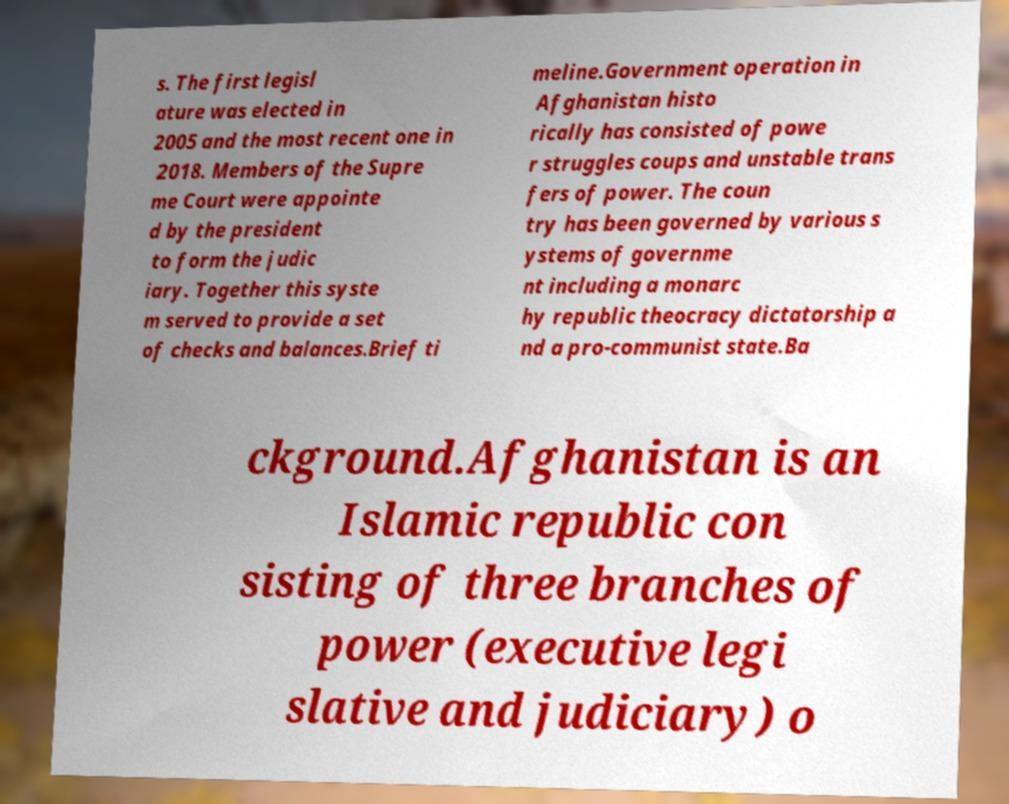I need the written content from this picture converted into text. Can you do that? s. The first legisl ature was elected in 2005 and the most recent one in 2018. Members of the Supre me Court were appointe d by the president to form the judic iary. Together this syste m served to provide a set of checks and balances.Brief ti meline.Government operation in Afghanistan histo rically has consisted of powe r struggles coups and unstable trans fers of power. The coun try has been governed by various s ystems of governme nt including a monarc hy republic theocracy dictatorship a nd a pro-communist state.Ba ckground.Afghanistan is an Islamic republic con sisting of three branches of power (executive legi slative and judiciary) o 